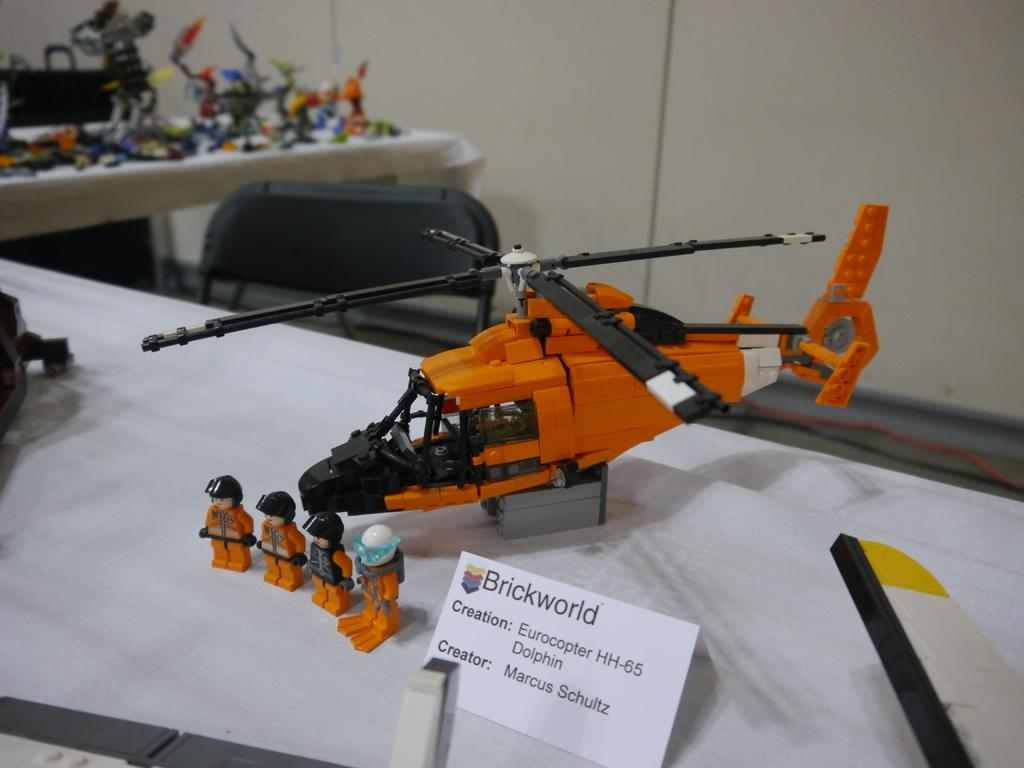<image>
Describe the image concisely. A toy lego helicopter created by Marcus Schultz on a table. 